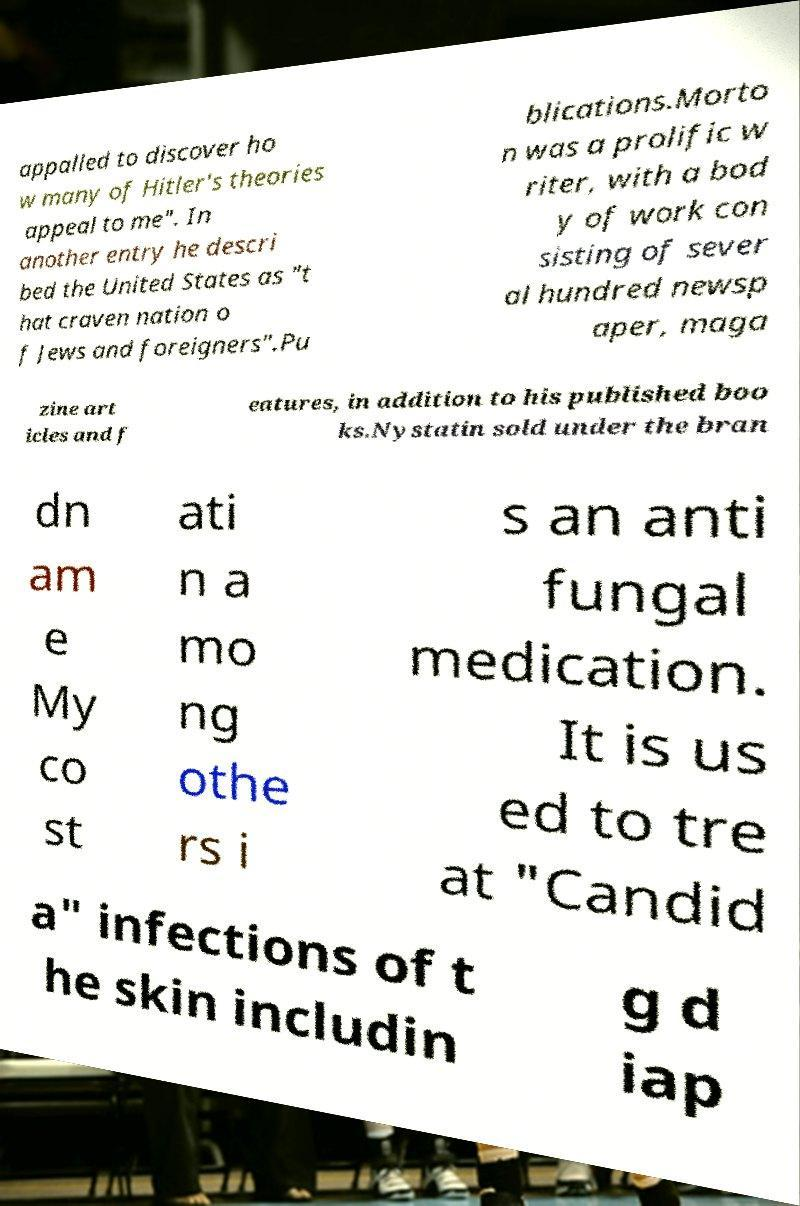Please identify and transcribe the text found in this image. appalled to discover ho w many of Hitler's theories appeal to me". In another entry he descri bed the United States as "t hat craven nation o f Jews and foreigners".Pu blications.Morto n was a prolific w riter, with a bod y of work con sisting of sever al hundred newsp aper, maga zine art icles and f eatures, in addition to his published boo ks.Nystatin sold under the bran dn am e My co st ati n a mo ng othe rs i s an anti fungal medication. It is us ed to tre at "Candid a" infections of t he skin includin g d iap 